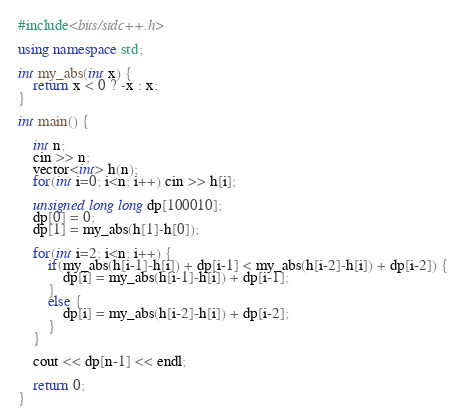Convert code to text. <code><loc_0><loc_0><loc_500><loc_500><_C++_>#include<bits/stdc++.h>

using namespace std;

int my_abs(int x) {
    return x < 0 ? -x : x;
}

int main() {

    int n;
    cin >> n;
    vector<int> h(n);
    for(int i=0; i<n; i++) cin >> h[i];

    unsigned long long dp[100010];
    dp[0] = 0;
    dp[1] = my_abs(h[1]-h[0]);

    for(int i=2; i<n; i++) {
        if(my_abs(h[i-1]-h[i]) + dp[i-1] < my_abs(h[i-2]-h[i]) + dp[i-2]) {
            dp[i] = my_abs(h[i-1]-h[i]) + dp[i-1];
        }
        else {
            dp[i] = my_abs(h[i-2]-h[i]) + dp[i-2];
        }
    }

    cout << dp[n-1] << endl;

    return 0;
}
</code> 